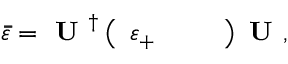<formula> <loc_0><loc_0><loc_500><loc_500>\bar { \bar { \varepsilon } } = U ^ { \dagger } \left ( \begin{array} { l l l } { \varepsilon _ { + } } \end{array} \right ) U ,</formula> 